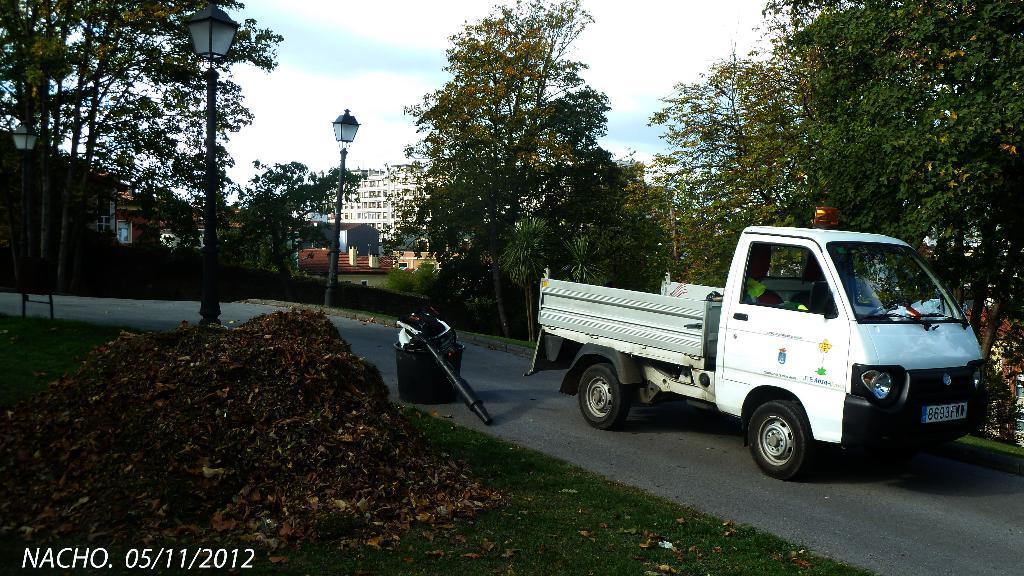Describe this image in one or two sentences. This picture is taken outside. There is a vehicle is on the road. There is a dustbin on the road. On both sides of road there are street lamps. There is trash on a grassy land. At the background there are few trees, buildings and sky. 